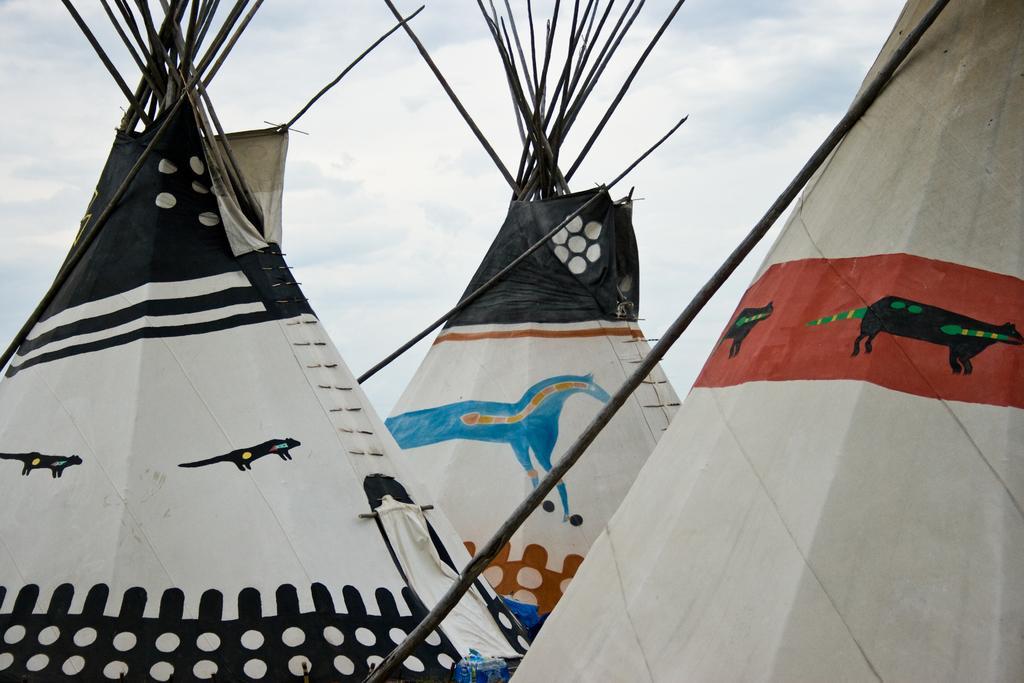Could you give a brief overview of what you see in this image? In this image we can see the three Tipi tents and in the background, we can see the sky with clouds. 